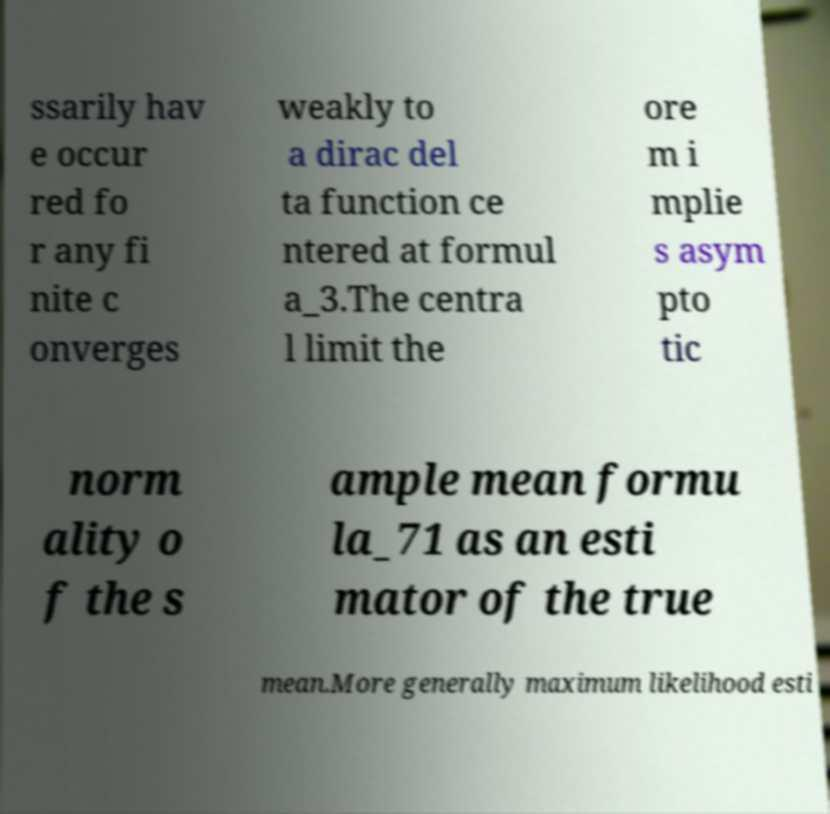I need the written content from this picture converted into text. Can you do that? ssarily hav e occur red fo r any fi nite c onverges weakly to a dirac del ta function ce ntered at formul a_3.The centra l limit the ore m i mplie s asym pto tic norm ality o f the s ample mean formu la_71 as an esti mator of the true mean.More generally maximum likelihood esti 